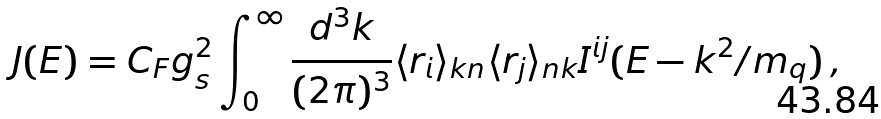Convert formula to latex. <formula><loc_0><loc_0><loc_500><loc_500>J ( E ) = C _ { F } g _ { s } ^ { 2 } \int _ { 0 } ^ { \infty } { \frac { d ^ { 3 } k } { ( 2 \pi ) ^ { 3 } } } \langle r _ { i } \rangle _ { { k } n } \langle r _ { j } \rangle _ { n { k } } I ^ { i j } ( E - k ^ { 2 } / m _ { q } ) \, ,</formula> 